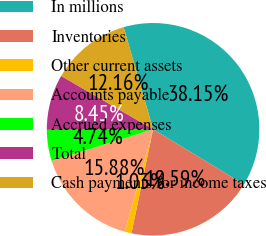<chart> <loc_0><loc_0><loc_500><loc_500><pie_chart><fcel>In millions<fcel>Inventories<fcel>Other current assets<fcel>Accounts payable<fcel>Accrued expenses<fcel>Total<fcel>Cash payments for income taxes<nl><fcel>38.15%<fcel>19.59%<fcel>1.03%<fcel>15.88%<fcel>4.74%<fcel>8.45%<fcel>12.16%<nl></chart> 